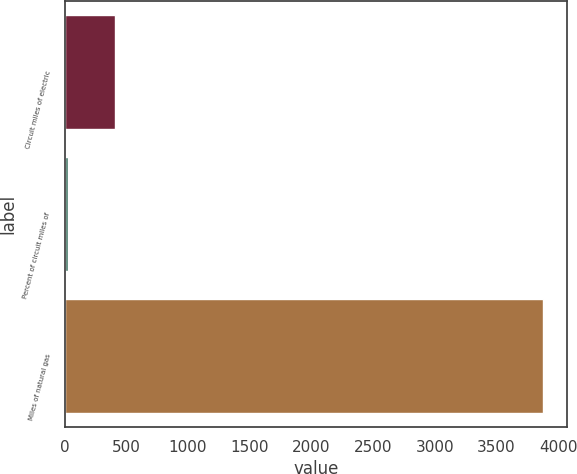Convert chart. <chart><loc_0><loc_0><loc_500><loc_500><bar_chart><fcel>Circuit miles of electric<fcel>Percent of circuit miles of<fcel>Miles of natural gas<nl><fcel>411.2<fcel>26<fcel>3878<nl></chart> 